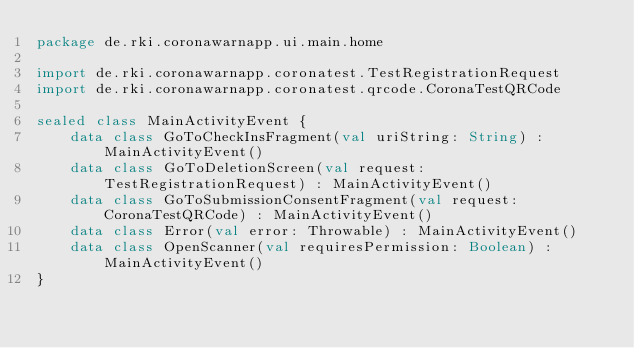<code> <loc_0><loc_0><loc_500><loc_500><_Kotlin_>package de.rki.coronawarnapp.ui.main.home

import de.rki.coronawarnapp.coronatest.TestRegistrationRequest
import de.rki.coronawarnapp.coronatest.qrcode.CoronaTestQRCode

sealed class MainActivityEvent {
    data class GoToCheckInsFragment(val uriString: String) : MainActivityEvent()
    data class GoToDeletionScreen(val request: TestRegistrationRequest) : MainActivityEvent()
    data class GoToSubmissionConsentFragment(val request: CoronaTestQRCode) : MainActivityEvent()
    data class Error(val error: Throwable) : MainActivityEvent()
    data class OpenScanner(val requiresPermission: Boolean) : MainActivityEvent()
}
</code> 